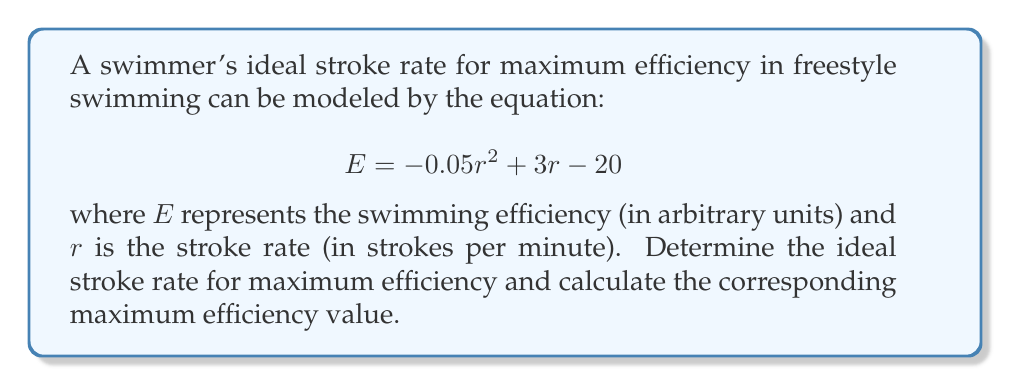Help me with this question. To find the ideal stroke rate for maximum efficiency, we need to find the maximum point of the quadratic function $E(r) = -0.05r^2 + 3r - 20$.

1. Find the derivative of $E$ with respect to $r$:
   $$ \frac{dE}{dr} = -0.1r + 3 $$

2. Set the derivative equal to zero to find the critical point:
   $$ -0.1r + 3 = 0 $$
   $$ -0.1r = -3 $$
   $$ r = 30 $$

3. Verify that this critical point is a maximum by checking the second derivative:
   $$ \frac{d^2E}{dr^2} = -0.1 < 0 $$
   Since the second derivative is negative, the critical point is indeed a maximum.

4. Calculate the maximum efficiency by substituting $r = 30$ into the original equation:
   $$ E = -0.05(30)^2 + 3(30) - 20 $$
   $$ E = -0.05(900) + 90 - 20 $$
   $$ E = -45 + 90 - 20 $$
   $$ E = 25 $$

Therefore, the ideal stroke rate for maximum efficiency is 30 strokes per minute, and the corresponding maximum efficiency value is 25 units.
Answer: Ideal stroke rate: 30 strokes per minute
Maximum efficiency: 25 units 